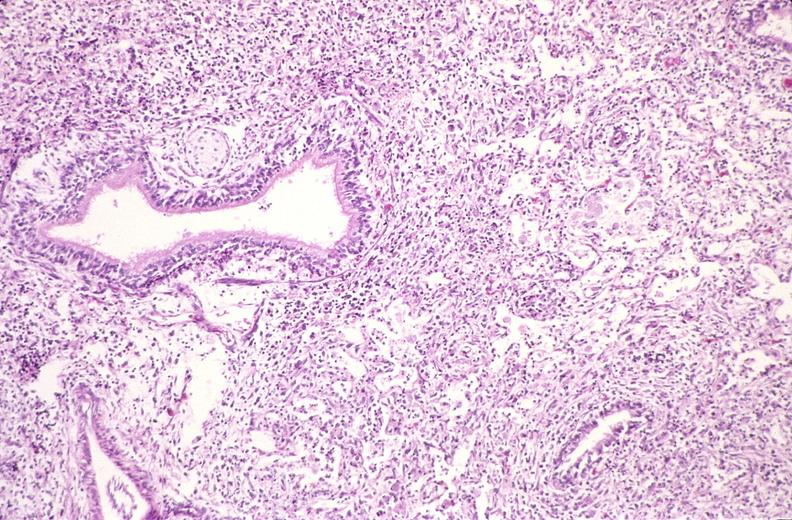s respiratory present?
Answer the question using a single word or phrase. Yes 